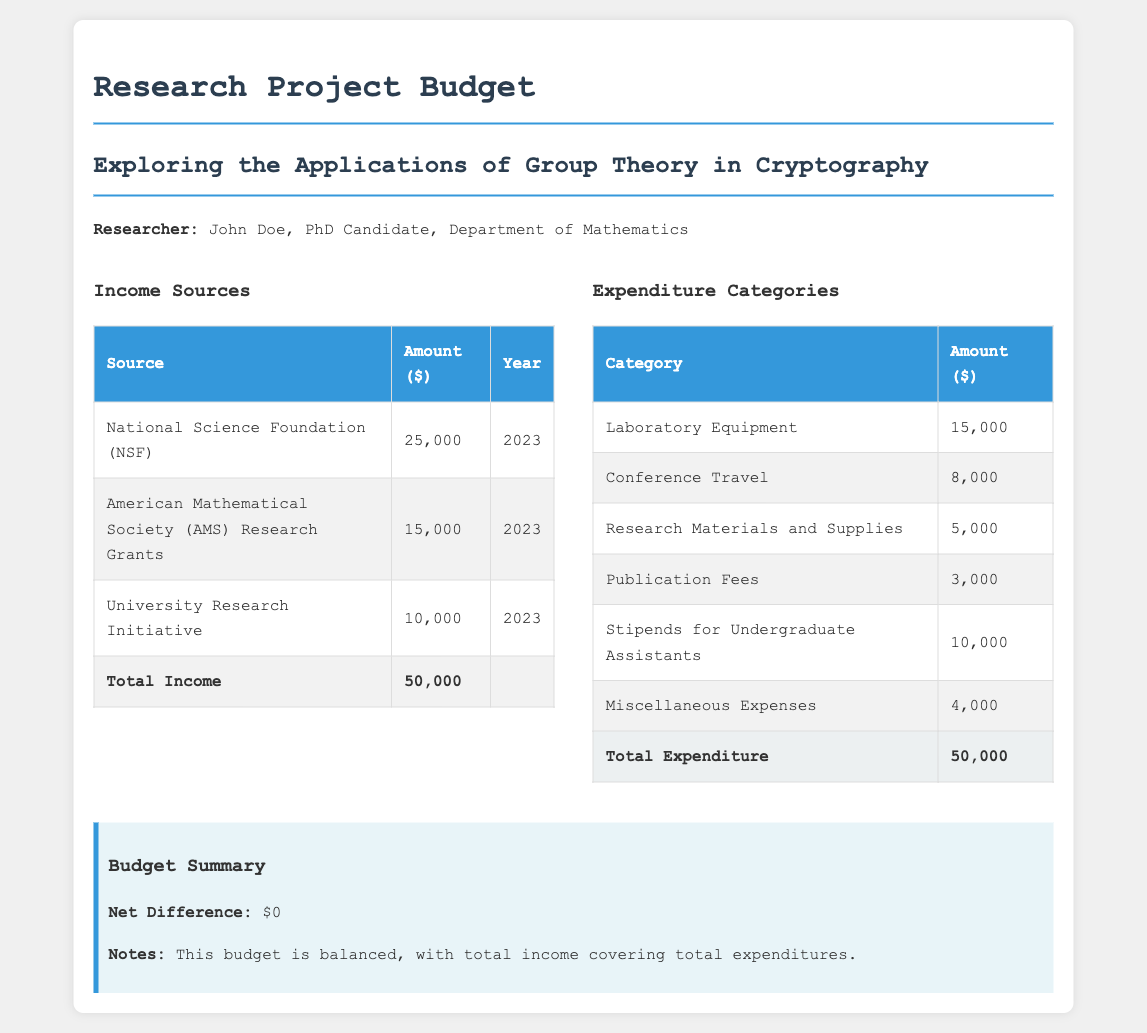what is the total income? The total income is calculated by adding all income sources listed in the document, which is 25,000 + 15,000 + 10,000 = 50,000.
Answer: 50,000 who is the researcher? The document states the researcher is John Doe, who is a PhD Candidate in the Department of Mathematics.
Answer: John Doe what is the amount for Laboratory Equipment? The document specifies that the amount allocated for Laboratory Equipment is 15,000.
Answer: 15,000 what is the total amount for Conference Travel? The document lists Conference Travel expenses as 8,000.
Answer: 8,000 what is the net difference as per the budget summary? The budget summary indicates a net difference, which is the total income minus total expenditure, resulting in 0.
Answer: 0 how much is allocated for Publication Fees? The document states that the amount allocated for Publication Fees is 3,000.
Answer: 3,000 which funding source provided the least amount? By reviewing the income sources, the University Research Initiative provided the least amount, which is 10,000.
Answer: University Research Initiative what is the purpose of this research project? The title of the research project is Exploring the Applications of Group Theory in Cryptography.
Answer: Exploring the Applications of Group Theory in Cryptography 